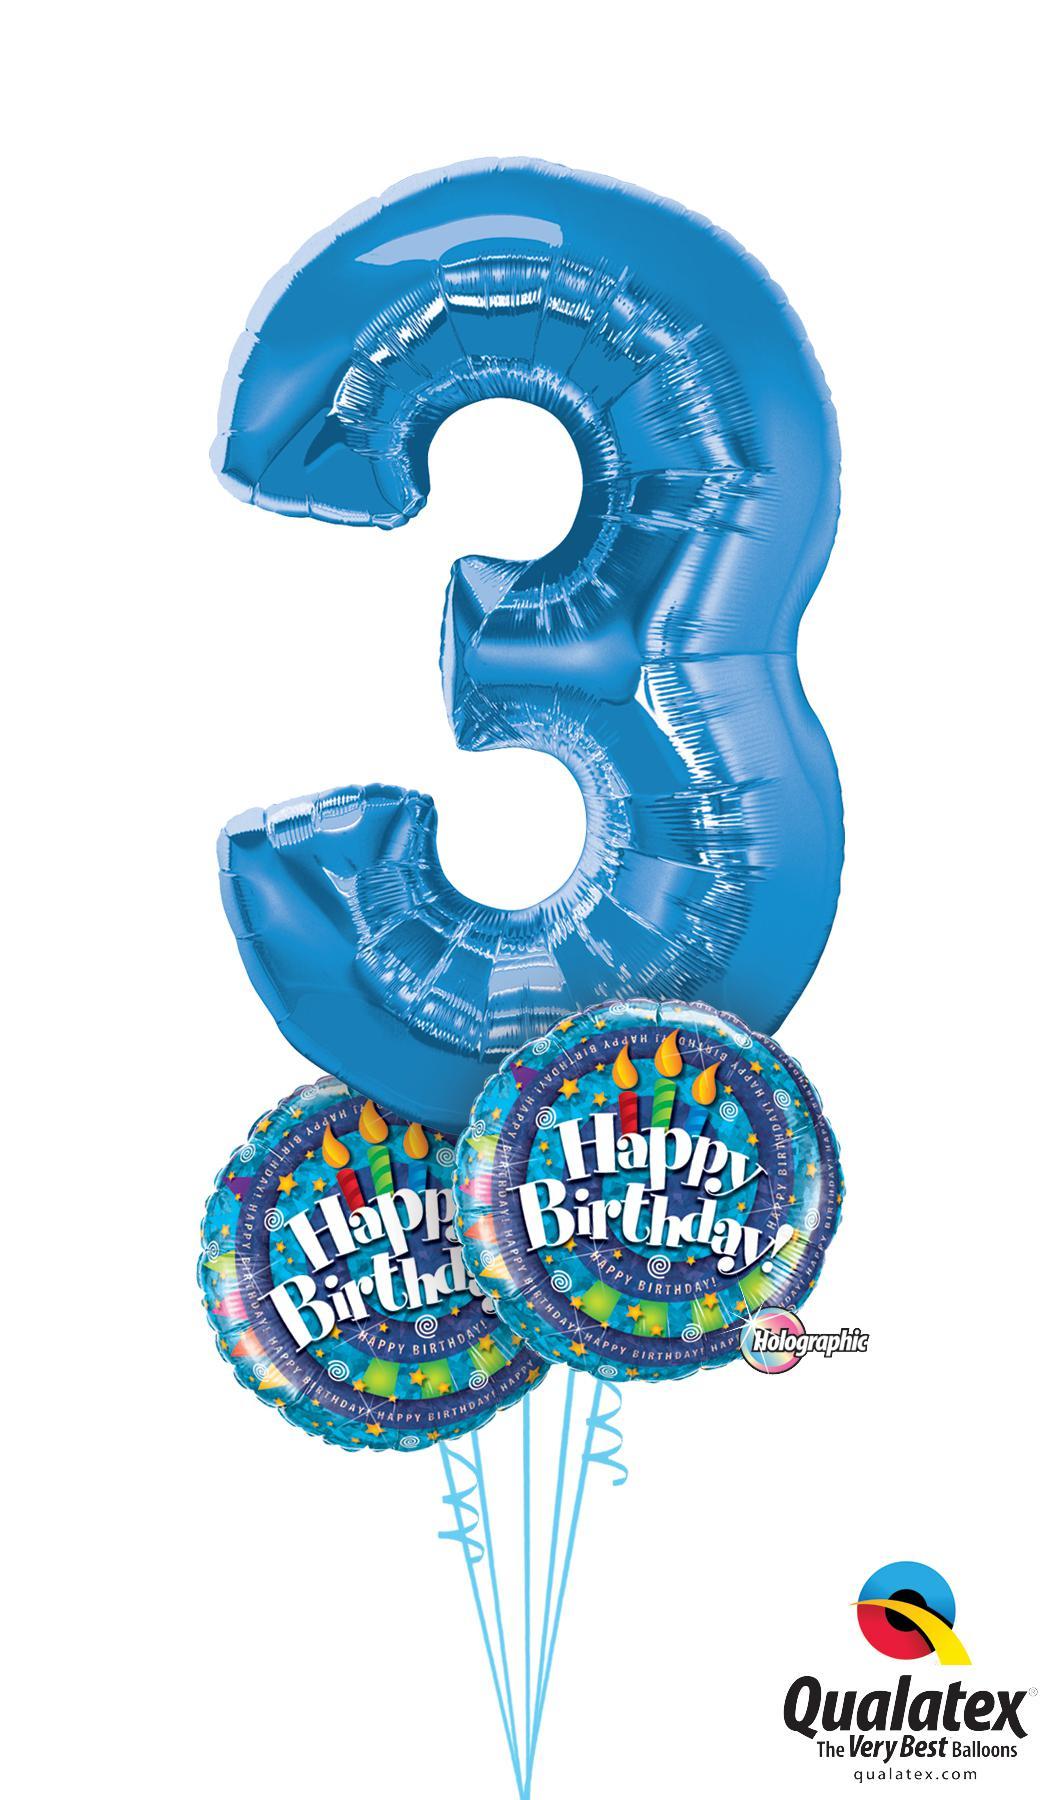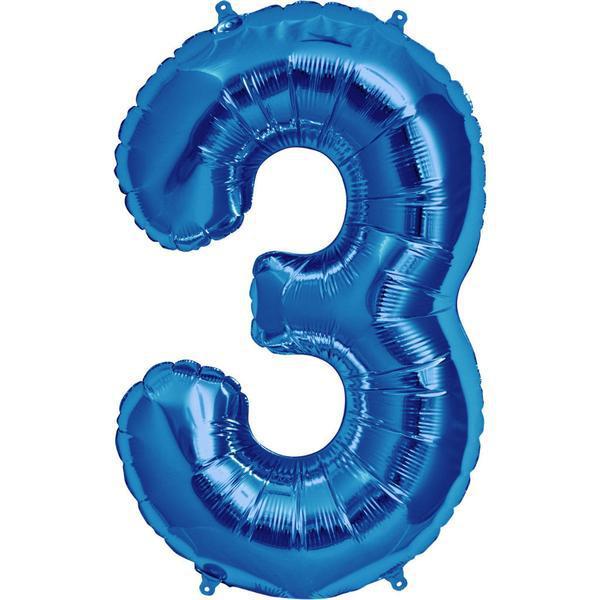The first image is the image on the left, the second image is the image on the right. Given the left and right images, does the statement "Each image contains exactly one purple item shaped like the number three." hold true? Answer yes or no. No. The first image is the image on the left, the second image is the image on the right. For the images displayed, is the sentence "All the number three balloons are blue." factually correct? Answer yes or no. Yes. 